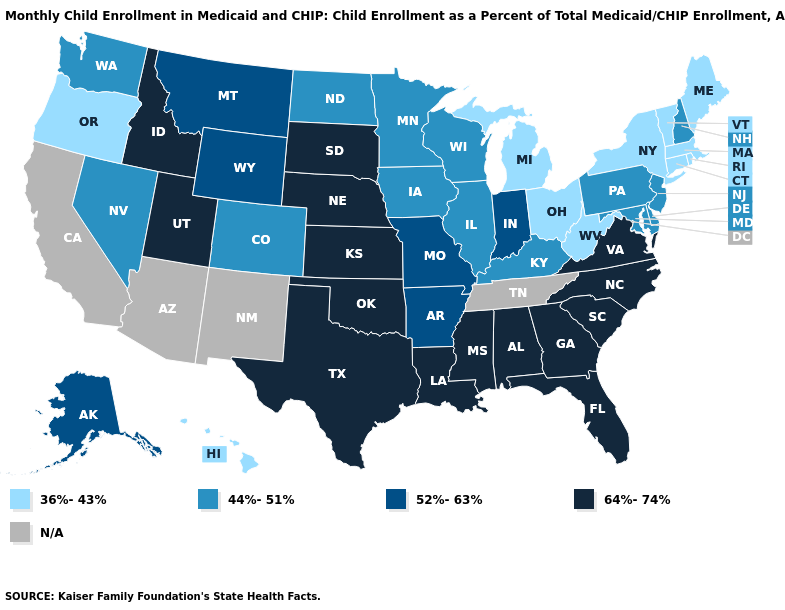What is the value of Utah?
Short answer required. 64%-74%. What is the lowest value in states that border South Carolina?
Write a very short answer. 64%-74%. Which states hav the highest value in the Northeast?
Be succinct. New Hampshire, New Jersey, Pennsylvania. What is the value of New York?
Give a very brief answer. 36%-43%. Name the states that have a value in the range N/A?
Answer briefly. Arizona, California, New Mexico, Tennessee. Which states hav the highest value in the Northeast?
Concise answer only. New Hampshire, New Jersey, Pennsylvania. What is the highest value in the MidWest ?
Concise answer only. 64%-74%. What is the highest value in states that border Mississippi?
Write a very short answer. 64%-74%. What is the value of Oregon?
Concise answer only. 36%-43%. Does the first symbol in the legend represent the smallest category?
Be succinct. Yes. Which states have the lowest value in the Northeast?
Quick response, please. Connecticut, Maine, Massachusetts, New York, Rhode Island, Vermont. Name the states that have a value in the range 64%-74%?
Quick response, please. Alabama, Florida, Georgia, Idaho, Kansas, Louisiana, Mississippi, Nebraska, North Carolina, Oklahoma, South Carolina, South Dakota, Texas, Utah, Virginia. What is the value of Maryland?
Give a very brief answer. 44%-51%. 